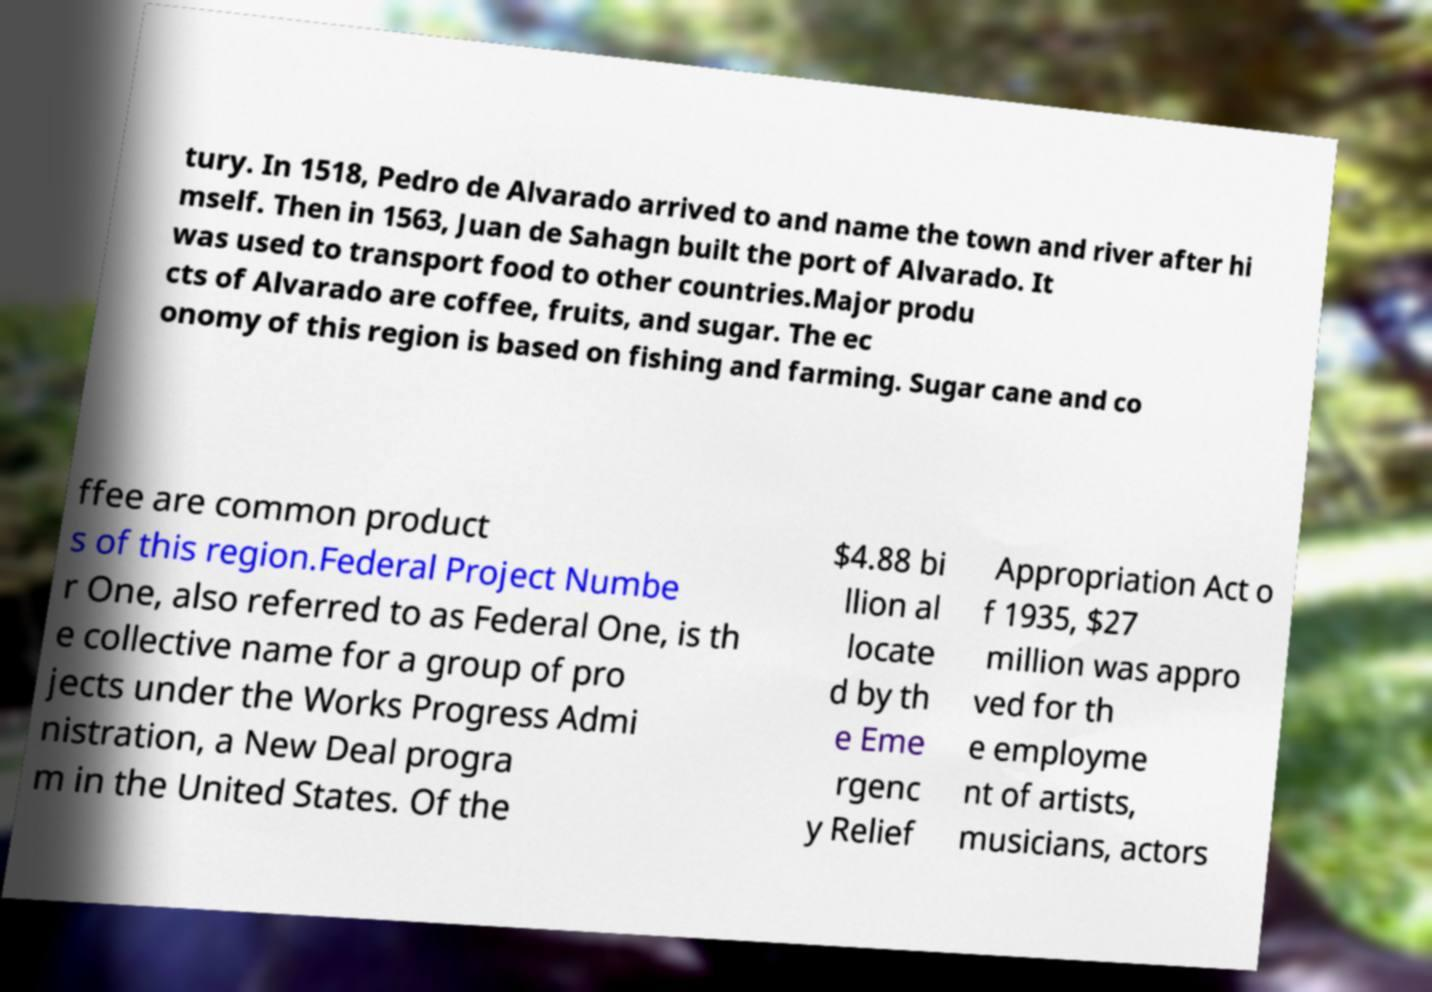Can you read and provide the text displayed in the image?This photo seems to have some interesting text. Can you extract and type it out for me? tury. In 1518, Pedro de Alvarado arrived to and name the town and river after hi mself. Then in 1563, Juan de Sahagn built the port of Alvarado. It was used to transport food to other countries.Major produ cts of Alvarado are coffee, fruits, and sugar. The ec onomy of this region is based on fishing and farming. Sugar cane and co ffee are common product s of this region.Federal Project Numbe r One, also referred to as Federal One, is th e collective name for a group of pro jects under the Works Progress Admi nistration, a New Deal progra m in the United States. Of the $4.88 bi llion al locate d by th e Eme rgenc y Relief Appropriation Act o f 1935, $27 million was appro ved for th e employme nt of artists, musicians, actors 